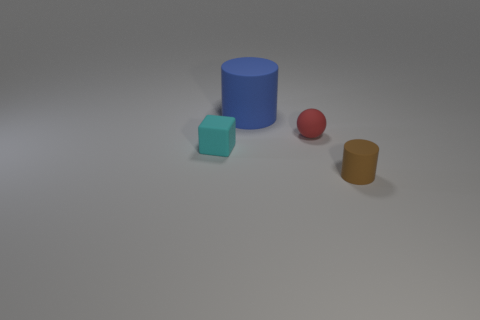Is there any other thing that is the same shape as the cyan matte object?
Offer a terse response. No. What is the size of the other thing that is the same shape as the big matte object?
Provide a succinct answer. Small. What number of small blocks have the same material as the big blue object?
Provide a succinct answer. 1. There is a tiny matte thing in front of the tiny cube; what number of blocks are in front of it?
Provide a succinct answer. 0. Are there any tiny blocks behind the cyan thing?
Make the answer very short. No. There is a tiny brown rubber thing that is in front of the big blue cylinder; does it have the same shape as the large blue thing?
Provide a succinct answer. Yes. What number of other spheres have the same color as the small sphere?
Your response must be concise. 0. There is a tiny matte thing that is behind the small object that is to the left of the large blue rubber cylinder; what shape is it?
Give a very brief answer. Sphere. Is there a green rubber object of the same shape as the large blue object?
Your answer should be very brief. No. Are there any brown matte cylinders of the same size as the red matte object?
Give a very brief answer. Yes. 